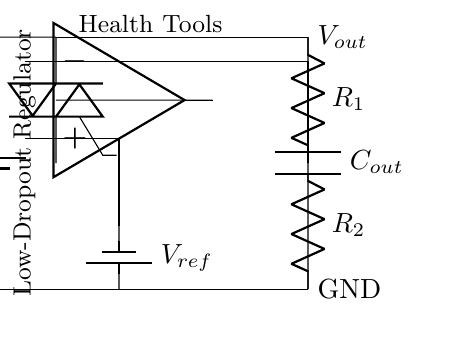What type of circuit is depicted here? The circuit is a low-dropout regulator, indicated by the presence of a pass transistor and a feedback network designed to maintain a consistent output voltage despite variations in the input voltage.
Answer: low-dropout regulator What is the function of the pass transistor in the circuit? The pass transistor functions to regulate the output voltage by allowing current to flow from the input to the output while minimizing voltage drop, which is essential for maintaining efficiency in low-voltage applications.
Answer: regulate output voltage What is the reference voltage provided in the circuit? The reference voltage is represented by V_ref, which is essential for the error amplifier to compare against the output voltage and adjust the pass transistor's gain, ensuring a steady output.
Answer: V_ref What do resistors R1 and R2 form in this circuit? Resistors R1 and R2 form a voltage divider, which is used to set the feedback voltage that the error amplifier uses to compare against the reference voltage, thus stabilizing the output.
Answer: voltage divider What is the role of the output capacitor C_out? The output capacitor C_out serves to stabilize the output voltage by smoothing out fluctuations in the output, providing a reservoir of charge to meet transient loads and enhance performance.
Answer: stabilize output voltage 